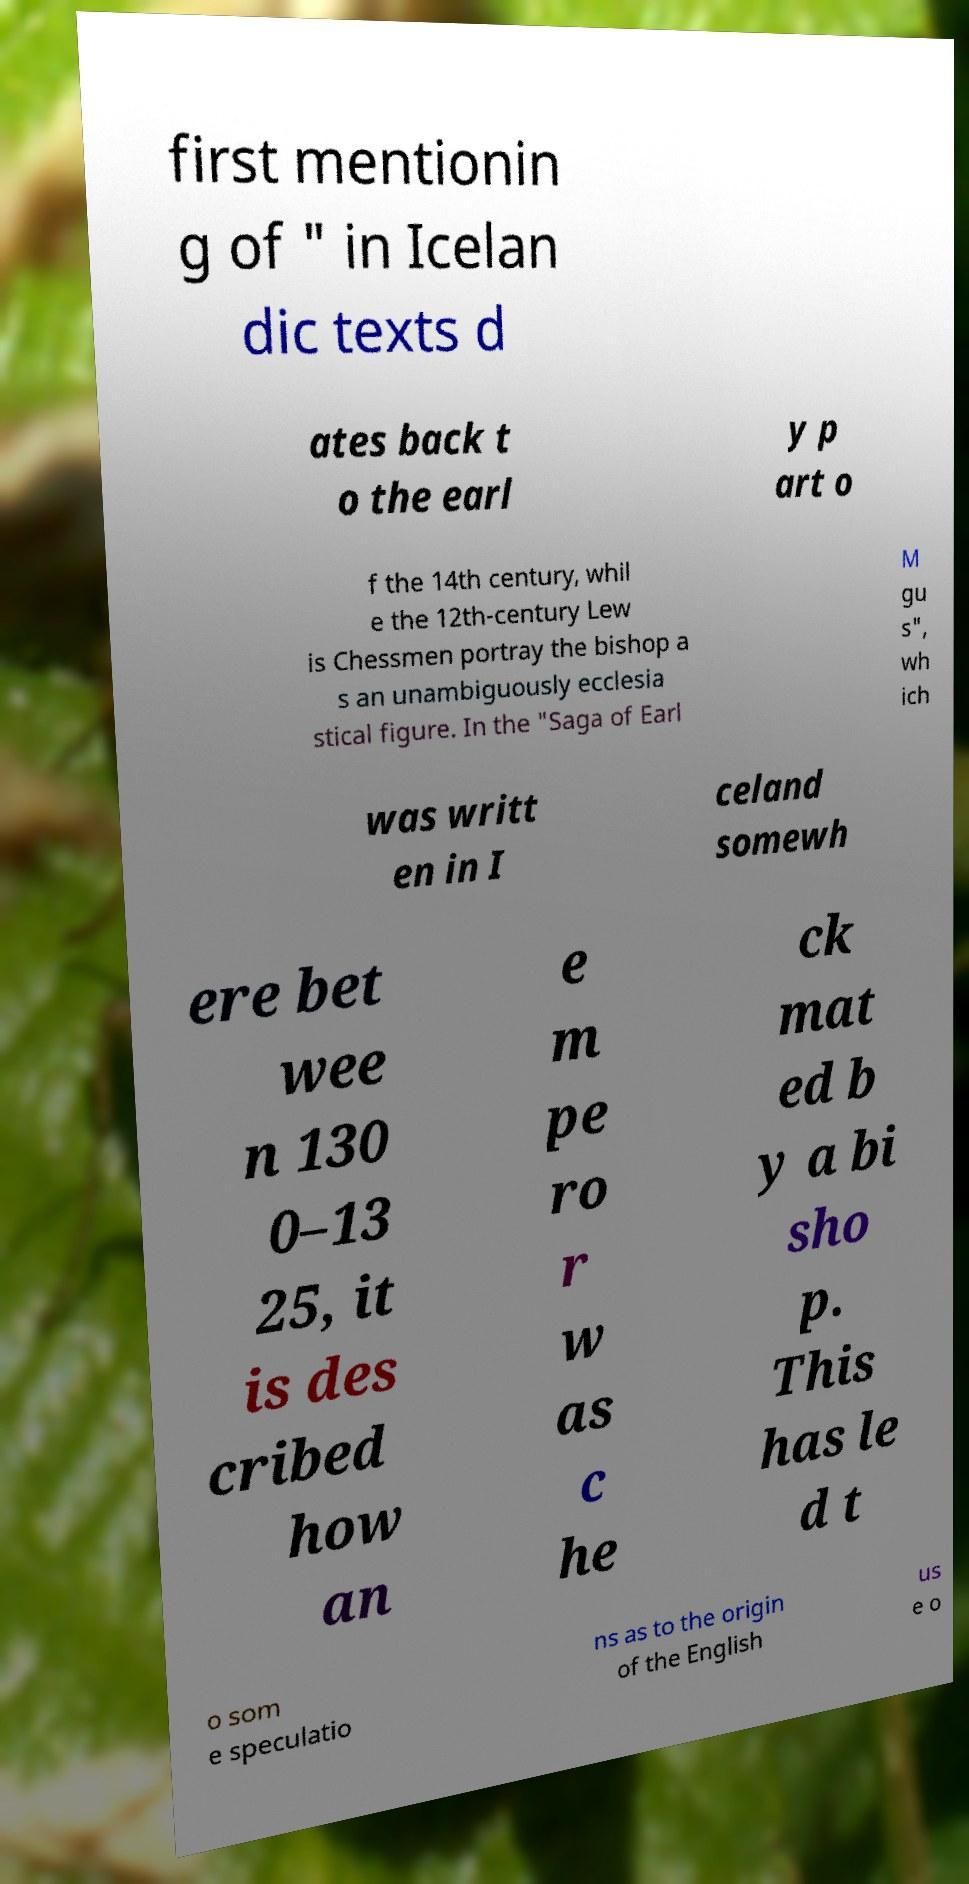Can you accurately transcribe the text from the provided image for me? first mentionin g of " in Icelan dic texts d ates back t o the earl y p art o f the 14th century, whil e the 12th-century Lew is Chessmen portray the bishop a s an unambiguously ecclesia stical figure. In the "Saga of Earl M gu s", wh ich was writt en in I celand somewh ere bet wee n 130 0–13 25, it is des cribed how an e m pe ro r w as c he ck mat ed b y a bi sho p. This has le d t o som e speculatio ns as to the origin of the English us e o 